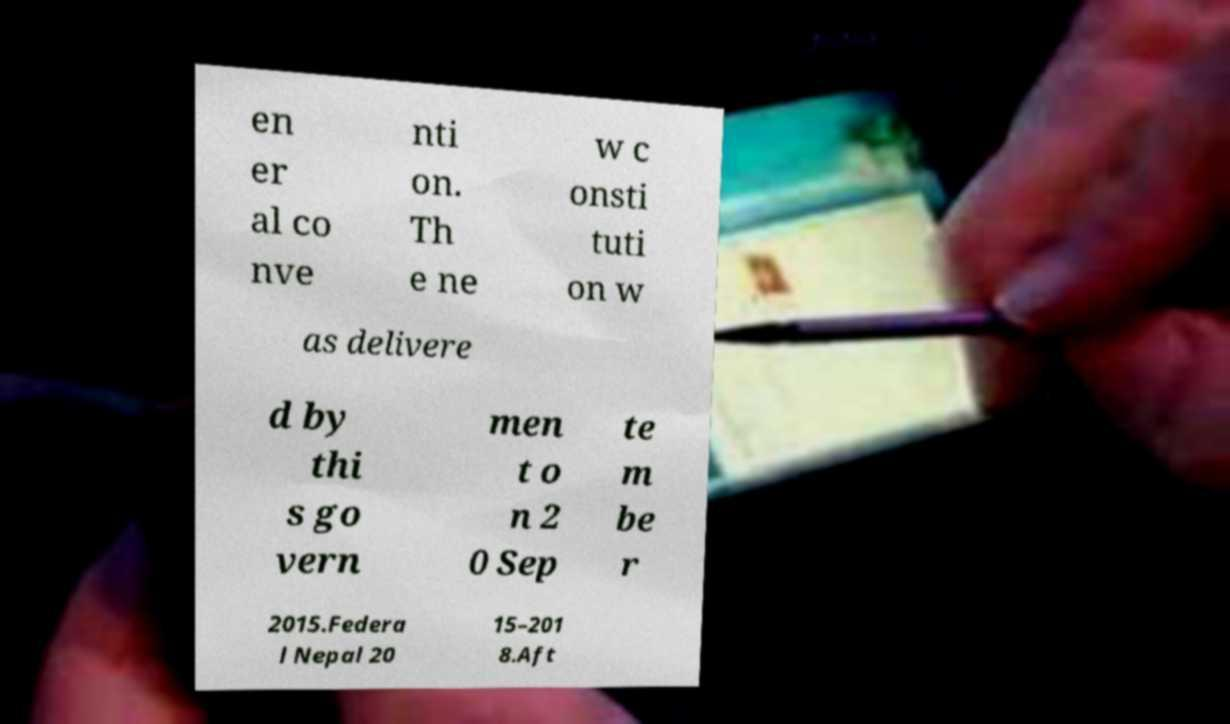Can you read and provide the text displayed in the image?This photo seems to have some interesting text. Can you extract and type it out for me? en er al co nve nti on. Th e ne w c onsti tuti on w as delivere d by thi s go vern men t o n 2 0 Sep te m be r 2015.Federa l Nepal 20 15–201 8.Aft 